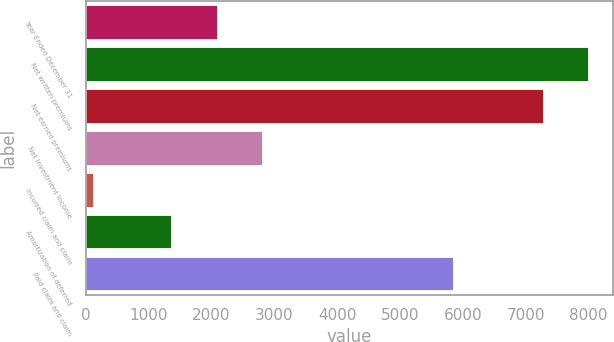Convert chart to OTSL. <chart><loc_0><loc_0><loc_500><loc_500><bar_chart><fcel>Year Ended December 31<fcel>Net written premiums<fcel>Net earned premiums<fcel>Net investment income<fcel>Incurred claim and claim<fcel>Amortization of deferred<fcel>Paid claim and claim<nl><fcel>2085.3<fcel>7994.3<fcel>7271<fcel>2808.6<fcel>115<fcel>1362<fcel>5836.3<nl></chart> 